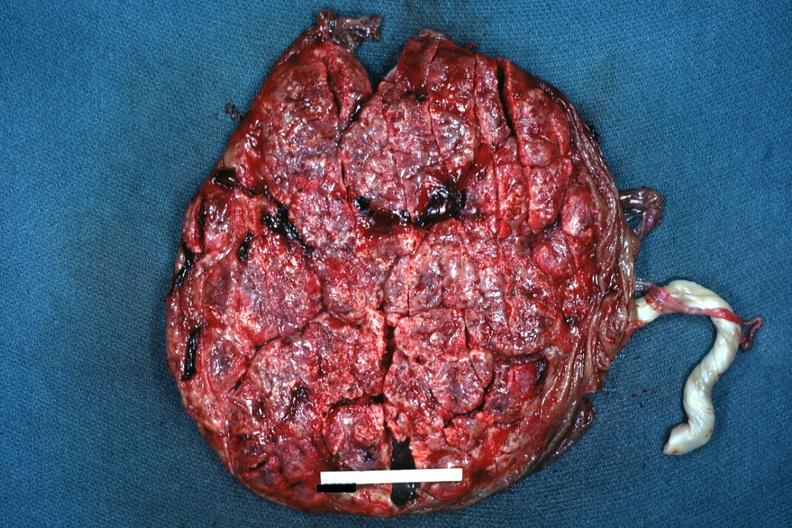does spina bifida show seen from fetal surface term placenta?
Answer the question using a single word or phrase. No 